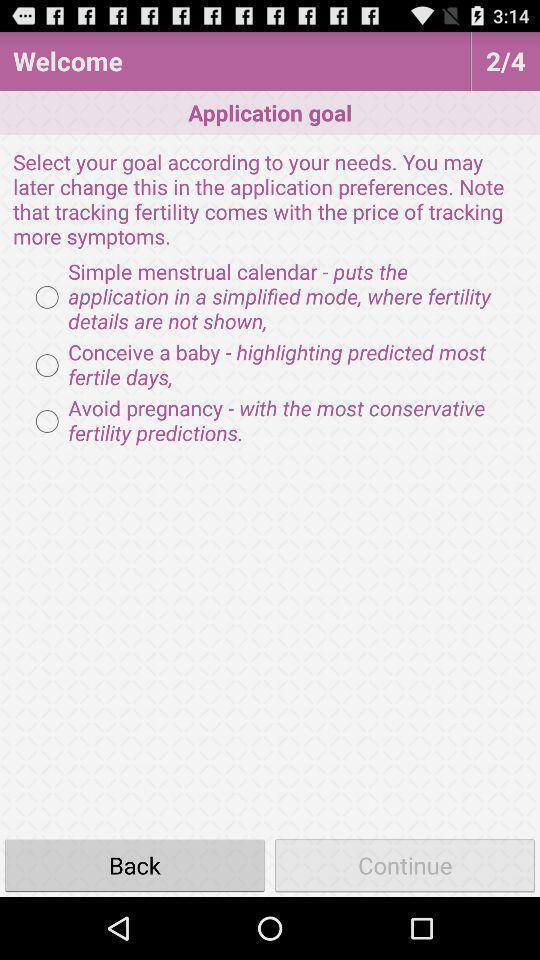Give me a narrative description of this picture. Welcome page of a health app. 